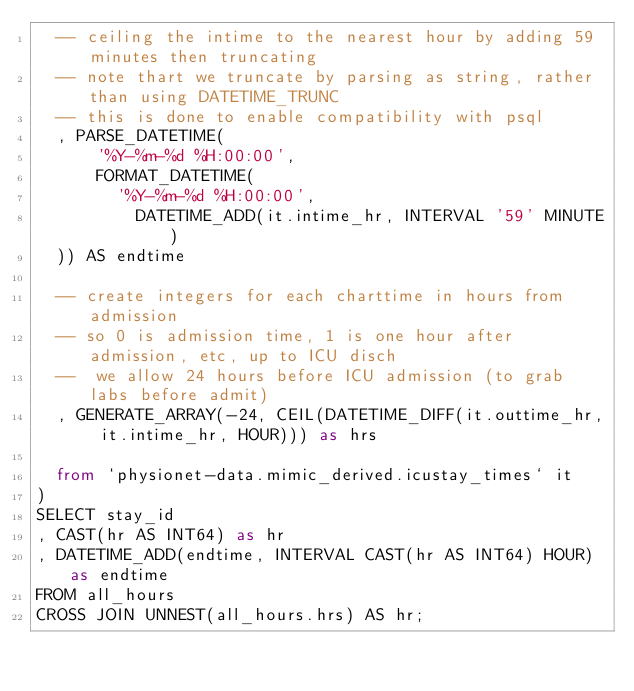<code> <loc_0><loc_0><loc_500><loc_500><_SQL_>  -- ceiling the intime to the nearest hour by adding 59 minutes then truncating
  -- note thart we truncate by parsing as string, rather than using DATETIME_TRUNC
  -- this is done to enable compatibility with psql
  , PARSE_DATETIME(
      '%Y-%m-%d %H:00:00',
      FORMAT_DATETIME(
        '%Y-%m-%d %H:00:00',
          DATETIME_ADD(it.intime_hr, INTERVAL '59' MINUTE)
  )) AS endtime

  -- create integers for each charttime in hours from admission
  -- so 0 is admission time, 1 is one hour after admission, etc, up to ICU disch
  --  we allow 24 hours before ICU admission (to grab labs before admit)
  , GENERATE_ARRAY(-24, CEIL(DATETIME_DIFF(it.outtime_hr, it.intime_hr, HOUR))) as hrs

  from `physionet-data.mimic_derived.icustay_times` it
)
SELECT stay_id
, CAST(hr AS INT64) as hr
, DATETIME_ADD(endtime, INTERVAL CAST(hr AS INT64) HOUR) as endtime
FROM all_hours
CROSS JOIN UNNEST(all_hours.hrs) AS hr;</code> 